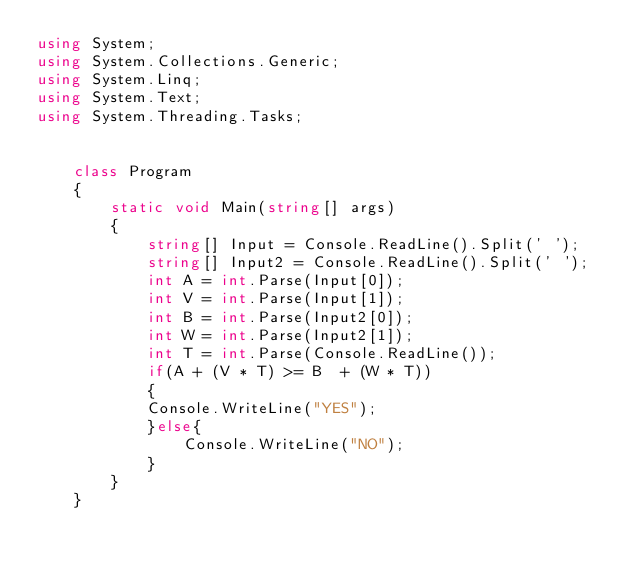<code> <loc_0><loc_0><loc_500><loc_500><_C#_>using System;
using System.Collections.Generic;
using System.Linq;
using System.Text;
using System.Threading.Tasks;


    class Program
    {
        static void Main(string[] args)
        {
            string[] Input = Console.ReadLine().Split(' ');
            string[] Input2 = Console.ReadLine().Split(' ');
            int A = int.Parse(Input[0]);
            int V = int.Parse(Input[1]);
            int B = int.Parse(Input2[0]);
            int W = int.Parse(Input2[1]);
            int T = int.Parse(Console.ReadLine());
            if(A + (V * T) >= B  + (W * T))
            {
            Console.WriteLine("YES");
            }else{
                Console.WriteLine("NO");
            }
        }
    }</code> 